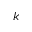<formula> <loc_0><loc_0><loc_500><loc_500>k</formula> 